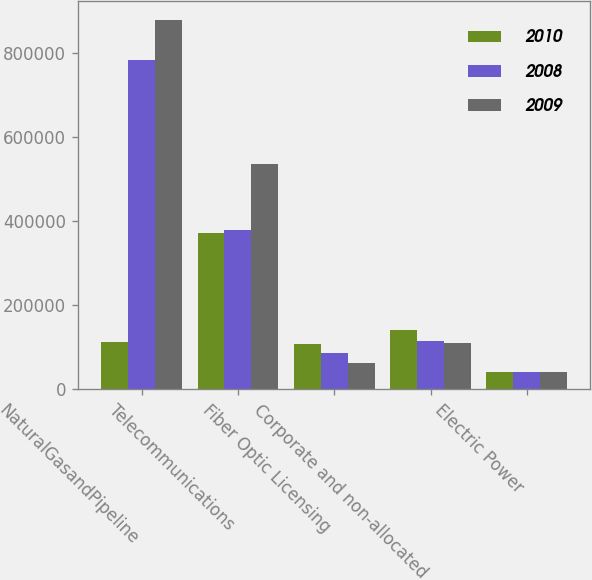Convert chart. <chart><loc_0><loc_0><loc_500><loc_500><stacked_bar_chart><ecel><fcel>NaturalGasandPipeline<fcel>Telecommunications<fcel>Fiber Optic Licensing<fcel>Corporate and non-allocated<fcel>Electric Power<nl><fcel>2010<fcel>112751<fcel>372934<fcel>106787<fcel>140480<fcel>40781<nl><fcel>2008<fcel>784657<fcel>378363<fcel>87261<fcel>116139<fcel>40284<nl><fcel>2009<fcel>879541<fcel>536778<fcel>62328<fcel>109363<fcel>40358<nl></chart> 